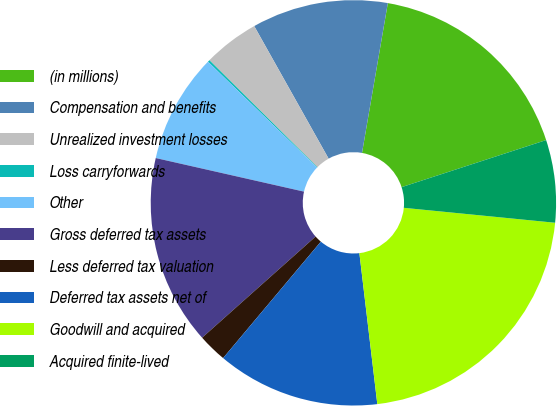Convert chart. <chart><loc_0><loc_0><loc_500><loc_500><pie_chart><fcel>(in millions)<fcel>Compensation and benefits<fcel>Unrealized investment losses<fcel>Loss carryforwards<fcel>Other<fcel>Gross deferred tax assets<fcel>Less deferred tax valuation<fcel>Deferred tax assets net of<fcel>Goodwill and acquired<fcel>Acquired finite-lived<nl><fcel>17.28%<fcel>10.86%<fcel>4.44%<fcel>0.16%<fcel>8.72%<fcel>15.14%<fcel>2.3%<fcel>13.0%<fcel>21.56%<fcel>6.58%<nl></chart> 